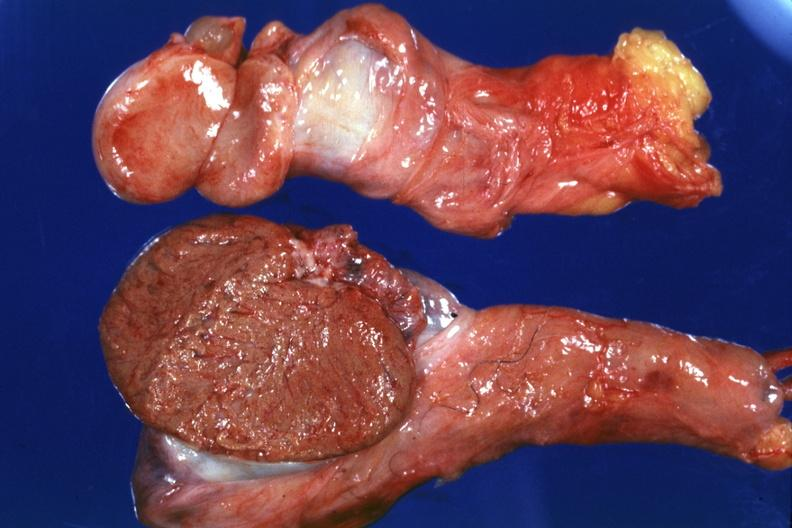does this image show that cut surface both testicles on normal and one quite small typical probably due to mumps have no history at this time?
Answer the question using a single word or phrase. Yes 